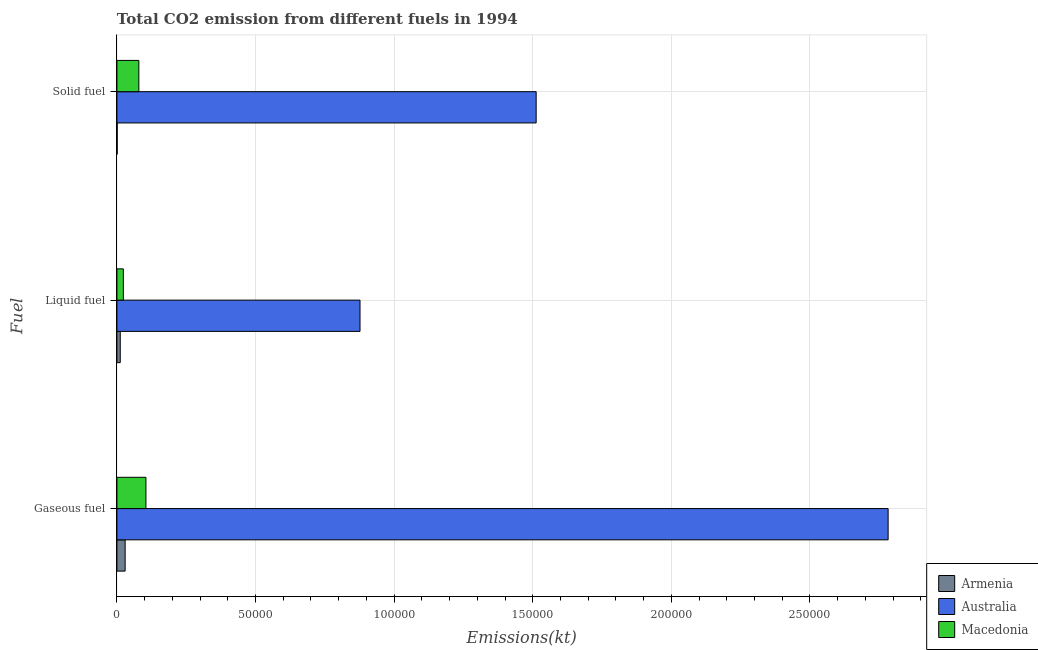How many different coloured bars are there?
Provide a succinct answer. 3. How many groups of bars are there?
Give a very brief answer. 3. Are the number of bars on each tick of the Y-axis equal?
Your answer should be very brief. Yes. How many bars are there on the 3rd tick from the top?
Provide a succinct answer. 3. What is the label of the 3rd group of bars from the top?
Offer a terse response. Gaseous fuel. What is the amount of co2 emissions from solid fuel in Armenia?
Offer a terse response. 95.34. Across all countries, what is the maximum amount of co2 emissions from gaseous fuel?
Give a very brief answer. 2.78e+05. Across all countries, what is the minimum amount of co2 emissions from solid fuel?
Offer a very short reply. 95.34. In which country was the amount of co2 emissions from liquid fuel minimum?
Provide a succinct answer. Armenia. What is the total amount of co2 emissions from liquid fuel in the graph?
Keep it short and to the point. 9.12e+04. What is the difference between the amount of co2 emissions from liquid fuel in Australia and that in Macedonia?
Offer a terse response. 8.54e+04. What is the difference between the amount of co2 emissions from liquid fuel in Armenia and the amount of co2 emissions from solid fuel in Australia?
Your answer should be compact. -1.50e+05. What is the average amount of co2 emissions from solid fuel per country?
Make the answer very short. 5.31e+04. What is the difference between the amount of co2 emissions from solid fuel and amount of co2 emissions from gaseous fuel in Armenia?
Keep it short and to the point. -2871.26. What is the ratio of the amount of co2 emissions from liquid fuel in Australia to that in Armenia?
Offer a terse response. 73.13. Is the amount of co2 emissions from solid fuel in Armenia less than that in Macedonia?
Keep it short and to the point. Yes. Is the difference between the amount of co2 emissions from solid fuel in Armenia and Australia greater than the difference between the amount of co2 emissions from liquid fuel in Armenia and Australia?
Offer a terse response. No. What is the difference between the highest and the second highest amount of co2 emissions from gaseous fuel?
Your answer should be compact. 2.68e+05. What is the difference between the highest and the lowest amount of co2 emissions from gaseous fuel?
Make the answer very short. 2.75e+05. In how many countries, is the amount of co2 emissions from gaseous fuel greater than the average amount of co2 emissions from gaseous fuel taken over all countries?
Offer a very short reply. 1. What does the 3rd bar from the top in Liquid fuel represents?
Your response must be concise. Armenia. What does the 1st bar from the bottom in Solid fuel represents?
Your answer should be compact. Armenia. How many bars are there?
Give a very brief answer. 9. Are all the bars in the graph horizontal?
Your answer should be very brief. Yes. How many countries are there in the graph?
Make the answer very short. 3. What is the difference between two consecutive major ticks on the X-axis?
Provide a short and direct response. 5.00e+04. Are the values on the major ticks of X-axis written in scientific E-notation?
Offer a terse response. No. Does the graph contain grids?
Provide a short and direct response. Yes. How are the legend labels stacked?
Give a very brief answer. Vertical. What is the title of the graph?
Offer a terse response. Total CO2 emission from different fuels in 1994. What is the label or title of the X-axis?
Keep it short and to the point. Emissions(kt). What is the label or title of the Y-axis?
Give a very brief answer. Fuel. What is the Emissions(kt) of Armenia in Gaseous fuel?
Offer a very short reply. 2966.6. What is the Emissions(kt) of Australia in Gaseous fuel?
Offer a very short reply. 2.78e+05. What is the Emissions(kt) in Macedonia in Gaseous fuel?
Make the answer very short. 1.05e+04. What is the Emissions(kt) of Armenia in Liquid fuel?
Your answer should be very brief. 1199.11. What is the Emissions(kt) in Australia in Liquid fuel?
Offer a terse response. 8.77e+04. What is the Emissions(kt) of Macedonia in Liquid fuel?
Provide a short and direct response. 2317.54. What is the Emissions(kt) in Armenia in Solid fuel?
Your answer should be very brief. 95.34. What is the Emissions(kt) of Australia in Solid fuel?
Ensure brevity in your answer.  1.51e+05. What is the Emissions(kt) in Macedonia in Solid fuel?
Ensure brevity in your answer.  7909.72. Across all Fuel, what is the maximum Emissions(kt) of Armenia?
Your answer should be very brief. 2966.6. Across all Fuel, what is the maximum Emissions(kt) in Australia?
Your response must be concise. 2.78e+05. Across all Fuel, what is the maximum Emissions(kt) of Macedonia?
Provide a succinct answer. 1.05e+04. Across all Fuel, what is the minimum Emissions(kt) in Armenia?
Keep it short and to the point. 95.34. Across all Fuel, what is the minimum Emissions(kt) of Australia?
Your response must be concise. 8.77e+04. Across all Fuel, what is the minimum Emissions(kt) of Macedonia?
Give a very brief answer. 2317.54. What is the total Emissions(kt) in Armenia in the graph?
Give a very brief answer. 4261.05. What is the total Emissions(kt) in Australia in the graph?
Provide a succinct answer. 5.17e+05. What is the total Emissions(kt) in Macedonia in the graph?
Give a very brief answer. 2.07e+04. What is the difference between the Emissions(kt) of Armenia in Gaseous fuel and that in Liquid fuel?
Give a very brief answer. 1767.49. What is the difference between the Emissions(kt) in Australia in Gaseous fuel and that in Liquid fuel?
Give a very brief answer. 1.91e+05. What is the difference between the Emissions(kt) of Macedonia in Gaseous fuel and that in Liquid fuel?
Offer a very short reply. 8151.74. What is the difference between the Emissions(kt) of Armenia in Gaseous fuel and that in Solid fuel?
Provide a succinct answer. 2871.26. What is the difference between the Emissions(kt) of Australia in Gaseous fuel and that in Solid fuel?
Offer a very short reply. 1.27e+05. What is the difference between the Emissions(kt) of Macedonia in Gaseous fuel and that in Solid fuel?
Make the answer very short. 2559.57. What is the difference between the Emissions(kt) in Armenia in Liquid fuel and that in Solid fuel?
Offer a terse response. 1103.77. What is the difference between the Emissions(kt) of Australia in Liquid fuel and that in Solid fuel?
Your answer should be compact. -6.35e+04. What is the difference between the Emissions(kt) of Macedonia in Liquid fuel and that in Solid fuel?
Your response must be concise. -5592.18. What is the difference between the Emissions(kt) in Armenia in Gaseous fuel and the Emissions(kt) in Australia in Liquid fuel?
Provide a short and direct response. -8.47e+04. What is the difference between the Emissions(kt) in Armenia in Gaseous fuel and the Emissions(kt) in Macedonia in Liquid fuel?
Offer a terse response. 649.06. What is the difference between the Emissions(kt) in Australia in Gaseous fuel and the Emissions(kt) in Macedonia in Liquid fuel?
Your answer should be very brief. 2.76e+05. What is the difference between the Emissions(kt) in Armenia in Gaseous fuel and the Emissions(kt) in Australia in Solid fuel?
Provide a succinct answer. -1.48e+05. What is the difference between the Emissions(kt) in Armenia in Gaseous fuel and the Emissions(kt) in Macedonia in Solid fuel?
Ensure brevity in your answer.  -4943.12. What is the difference between the Emissions(kt) in Australia in Gaseous fuel and the Emissions(kt) in Macedonia in Solid fuel?
Your answer should be compact. 2.70e+05. What is the difference between the Emissions(kt) of Armenia in Liquid fuel and the Emissions(kt) of Australia in Solid fuel?
Provide a succinct answer. -1.50e+05. What is the difference between the Emissions(kt) in Armenia in Liquid fuel and the Emissions(kt) in Macedonia in Solid fuel?
Your response must be concise. -6710.61. What is the difference between the Emissions(kt) of Australia in Liquid fuel and the Emissions(kt) of Macedonia in Solid fuel?
Your answer should be very brief. 7.98e+04. What is the average Emissions(kt) of Armenia per Fuel?
Offer a very short reply. 1420.35. What is the average Emissions(kt) of Australia per Fuel?
Provide a succinct answer. 1.72e+05. What is the average Emissions(kt) of Macedonia per Fuel?
Your answer should be very brief. 6898.85. What is the difference between the Emissions(kt) of Armenia and Emissions(kt) of Australia in Gaseous fuel?
Your response must be concise. -2.75e+05. What is the difference between the Emissions(kt) in Armenia and Emissions(kt) in Macedonia in Gaseous fuel?
Offer a terse response. -7502.68. What is the difference between the Emissions(kt) in Australia and Emissions(kt) in Macedonia in Gaseous fuel?
Your answer should be compact. 2.68e+05. What is the difference between the Emissions(kt) in Armenia and Emissions(kt) in Australia in Liquid fuel?
Provide a succinct answer. -8.65e+04. What is the difference between the Emissions(kt) in Armenia and Emissions(kt) in Macedonia in Liquid fuel?
Ensure brevity in your answer.  -1118.43. What is the difference between the Emissions(kt) of Australia and Emissions(kt) of Macedonia in Liquid fuel?
Provide a short and direct response. 8.54e+04. What is the difference between the Emissions(kt) of Armenia and Emissions(kt) of Australia in Solid fuel?
Your response must be concise. -1.51e+05. What is the difference between the Emissions(kt) of Armenia and Emissions(kt) of Macedonia in Solid fuel?
Keep it short and to the point. -7814.38. What is the difference between the Emissions(kt) of Australia and Emissions(kt) of Macedonia in Solid fuel?
Give a very brief answer. 1.43e+05. What is the ratio of the Emissions(kt) of Armenia in Gaseous fuel to that in Liquid fuel?
Provide a short and direct response. 2.47. What is the ratio of the Emissions(kt) in Australia in Gaseous fuel to that in Liquid fuel?
Give a very brief answer. 3.17. What is the ratio of the Emissions(kt) in Macedonia in Gaseous fuel to that in Liquid fuel?
Offer a very short reply. 4.52. What is the ratio of the Emissions(kt) of Armenia in Gaseous fuel to that in Solid fuel?
Make the answer very short. 31.12. What is the ratio of the Emissions(kt) in Australia in Gaseous fuel to that in Solid fuel?
Make the answer very short. 1.84. What is the ratio of the Emissions(kt) of Macedonia in Gaseous fuel to that in Solid fuel?
Keep it short and to the point. 1.32. What is the ratio of the Emissions(kt) in Armenia in Liquid fuel to that in Solid fuel?
Offer a terse response. 12.58. What is the ratio of the Emissions(kt) of Australia in Liquid fuel to that in Solid fuel?
Ensure brevity in your answer.  0.58. What is the ratio of the Emissions(kt) in Macedonia in Liquid fuel to that in Solid fuel?
Provide a short and direct response. 0.29. What is the difference between the highest and the second highest Emissions(kt) in Armenia?
Ensure brevity in your answer.  1767.49. What is the difference between the highest and the second highest Emissions(kt) in Australia?
Your response must be concise. 1.27e+05. What is the difference between the highest and the second highest Emissions(kt) in Macedonia?
Keep it short and to the point. 2559.57. What is the difference between the highest and the lowest Emissions(kt) in Armenia?
Offer a very short reply. 2871.26. What is the difference between the highest and the lowest Emissions(kt) of Australia?
Your answer should be very brief. 1.91e+05. What is the difference between the highest and the lowest Emissions(kt) in Macedonia?
Give a very brief answer. 8151.74. 